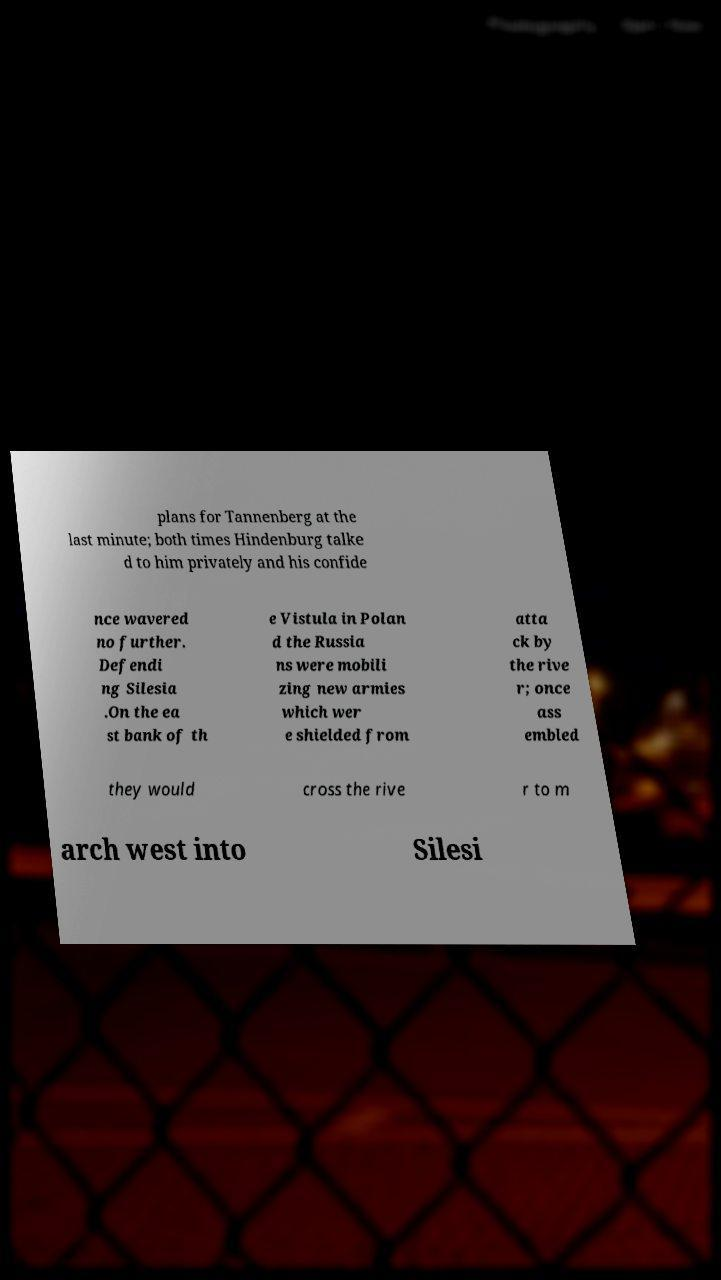Can you accurately transcribe the text from the provided image for me? plans for Tannenberg at the last minute; both times Hindenburg talke d to him privately and his confide nce wavered no further. Defendi ng Silesia .On the ea st bank of th e Vistula in Polan d the Russia ns were mobili zing new armies which wer e shielded from atta ck by the rive r; once ass embled they would cross the rive r to m arch west into Silesi 